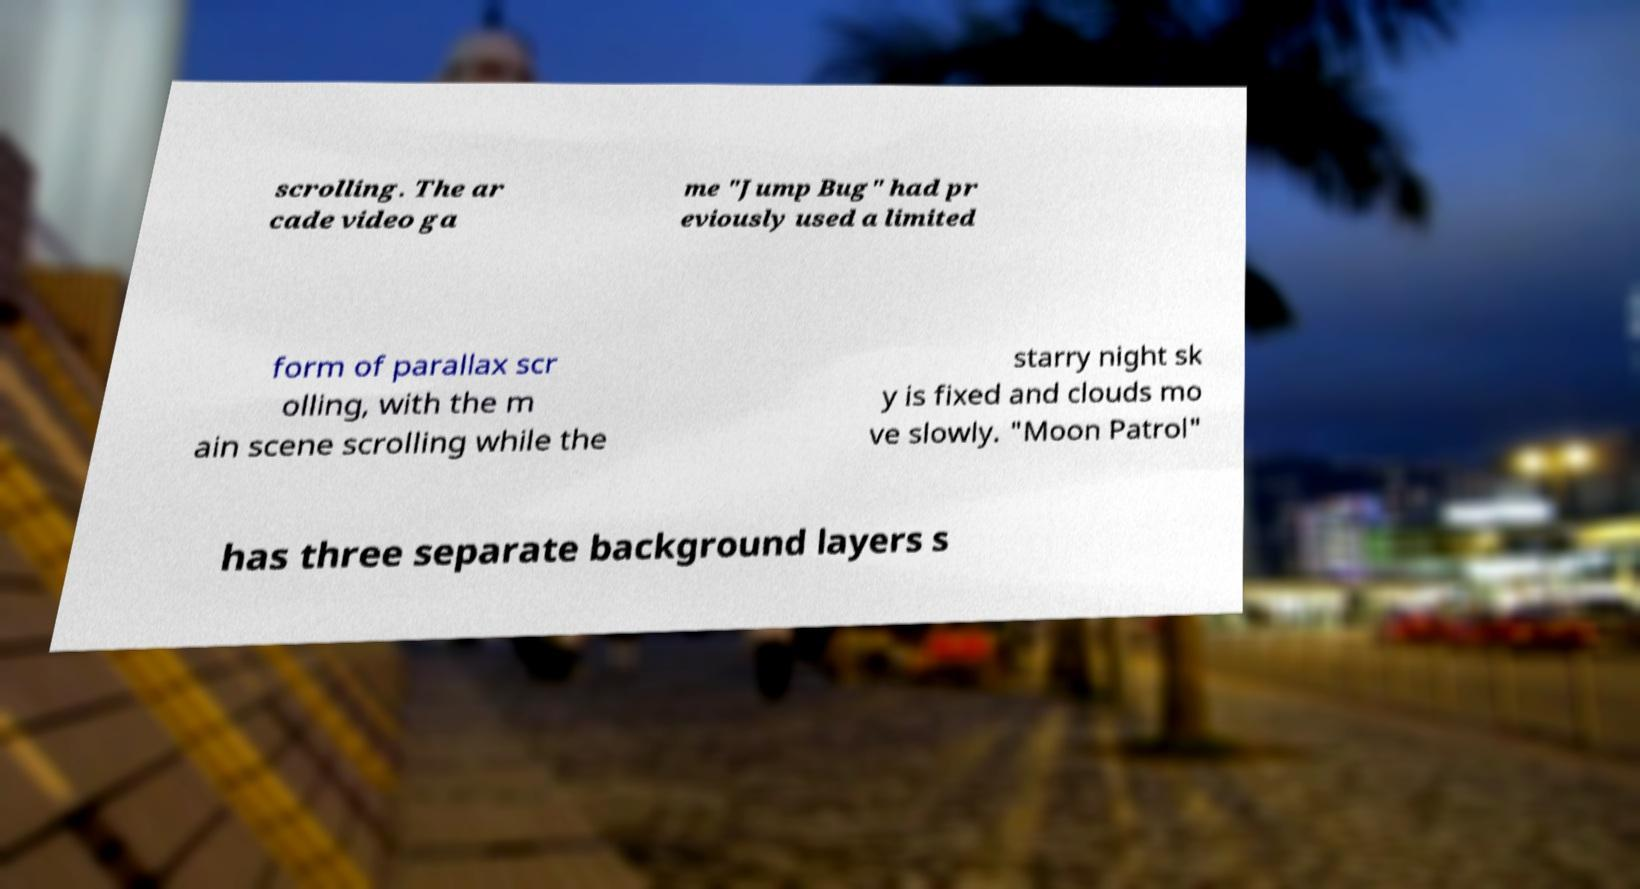Could you extract and type out the text from this image? scrolling. The ar cade video ga me "Jump Bug" had pr eviously used a limited form of parallax scr olling, with the m ain scene scrolling while the starry night sk y is fixed and clouds mo ve slowly. "Moon Patrol" has three separate background layers s 